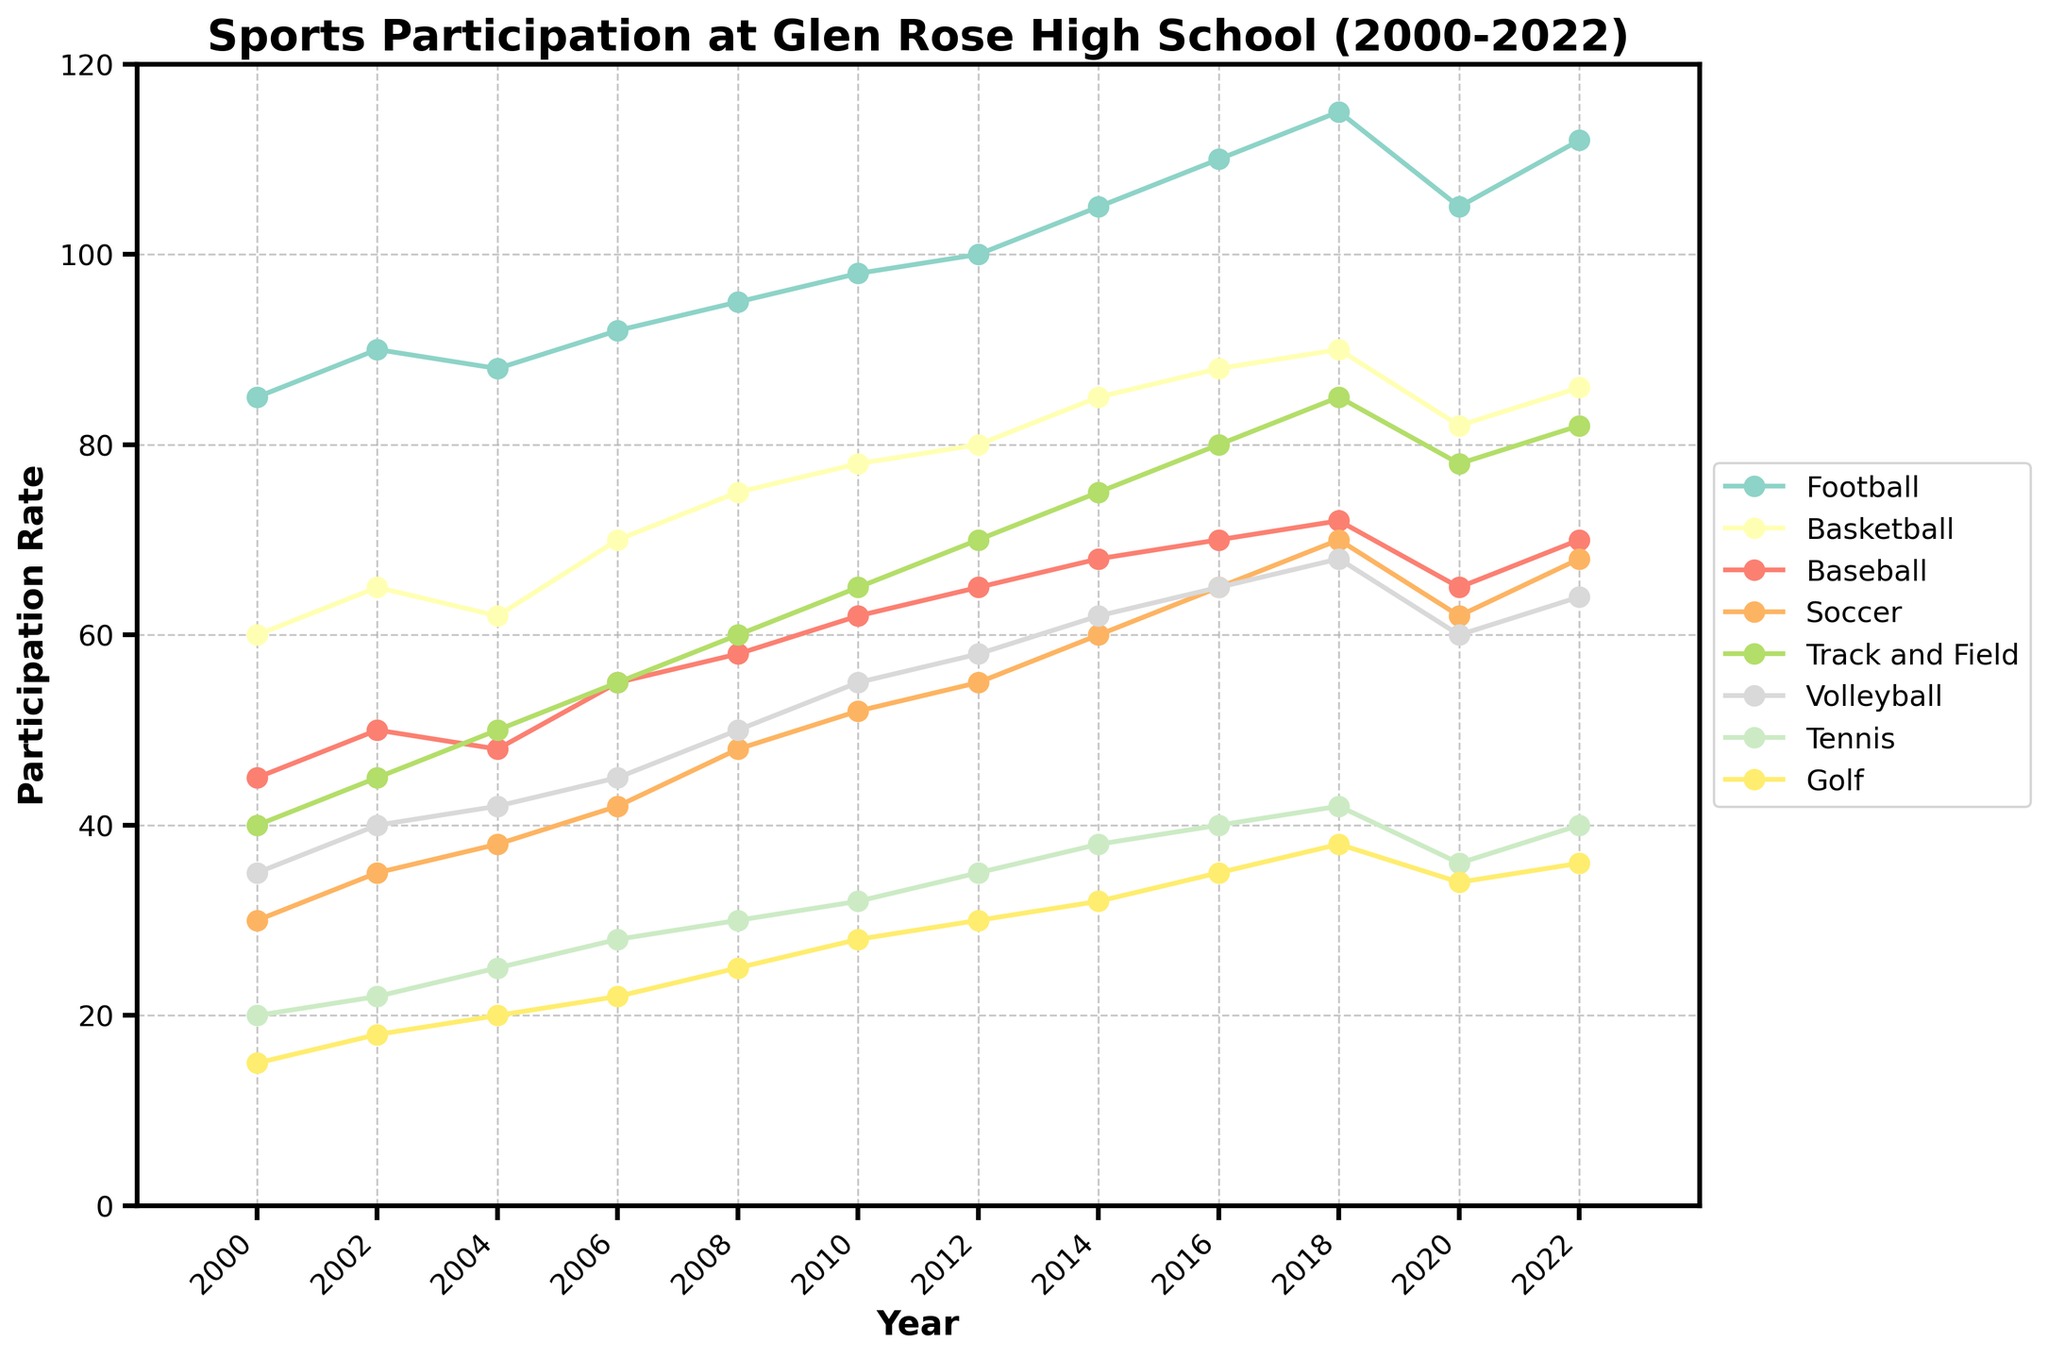Which sport saw the highest participation rate in 2022? Look at the year 2022 on the x-axis and identify which sport has the highest value on the y-axis. Football has the highest value at 112.
Answer: Football Has participation in Soccer increased or decreased over time? Follow the line representing Soccer from 2000 to 2022. The line shows an overall upward trend from 30 to 68, indicating an increase over time.
Answer: Increased What is the average participation rate in Track and Field from 2000 to 2022? Sum the participation rates for Track and Field from 2000 to 2022 and divide by the number of data points. (40 + 45 + 50 + 55 + 60 + 65 + 70 + 75 + 80 + 85 + 78 + 82) / 12 = 64.67
Answer: 64.67 Which sport had the biggest drop in participation between 2018 and 2020? Calculate the differences in participation rates between 2018 and 2020 for each sport, and identify the largest decrease. Football dropped from 115 to 105, a decrease of 10, which is the largest.
Answer: Football What is the trend of Volleyball participation from 2000 to 2022? Examine the line representing Volleyball from 2000 to 2022. The line shows a general upward trend from 35 to 64.
Answer: Increasing Which sports had participation rates that never surpassed 50? Identify lines that never reach the value 50 on the y-axis. Tennis and Golf both stay below 50 in all years.
Answer: Tennis, Golf What is the difference in participation between Soccer and Baseball in 2010? Find and subtract the participation rates of Soccer and Baseball in 2010 from 52 and 62, respectively. 62 - 52 = 10.
Answer: 10 By how much did participation in Basketball increase from 2000 to 2022? Subtract Basketball's participation rate in 2000 from its rate in 2022. 86 - 60 = 26.
Answer: 26 Which sport's participation rate increased the most between 2000 and 2022? Calculate the difference for each sport between 2000 and 2022 and identify the largest increase. Football increased from 85 to 112, a difference of 27, which is the largest.
Answer: Football In which year did Baseball see its lowest participation rate within the given range? Identify the lowest data point on the Baseball line. The lowest participation rate for Baseball is 45 in 2000.
Answer: 2000 